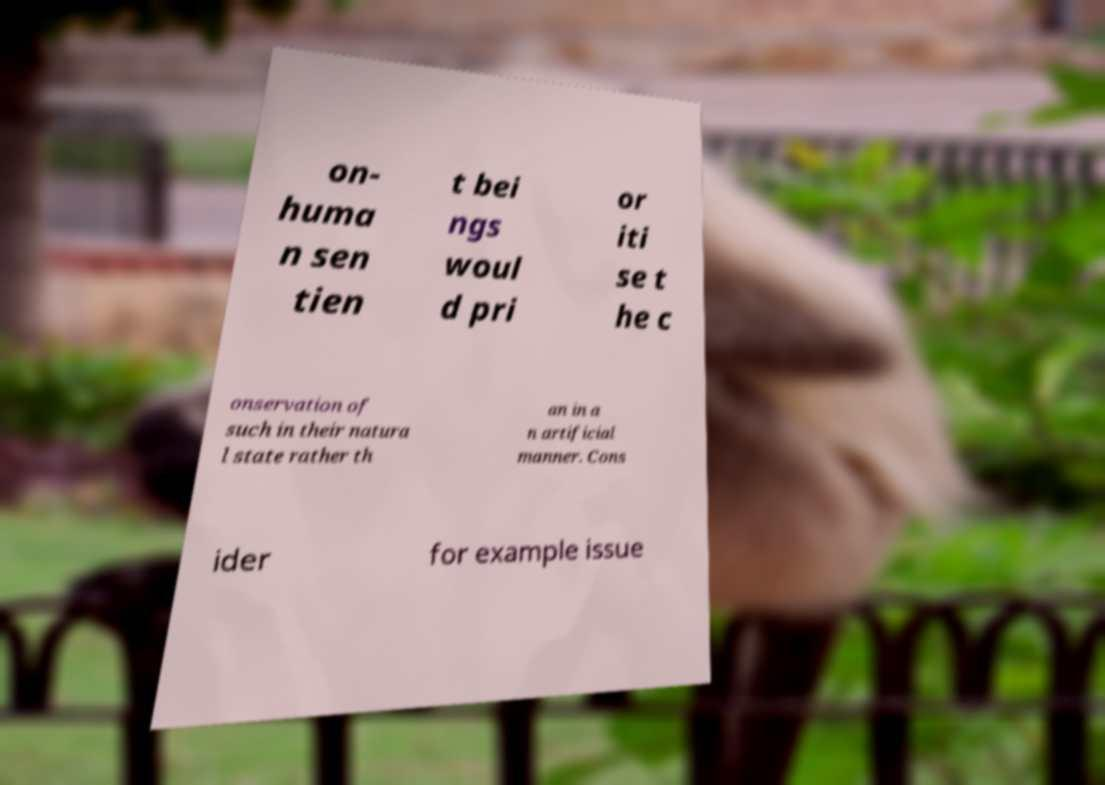Please identify and transcribe the text found in this image. on- huma n sen tien t bei ngs woul d pri or iti se t he c onservation of such in their natura l state rather th an in a n artificial manner. Cons ider for example issue 